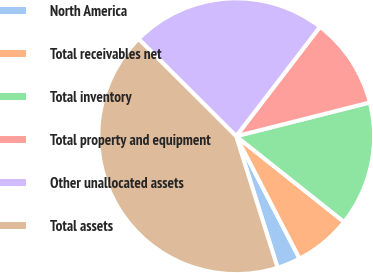Convert chart to OTSL. <chart><loc_0><loc_0><loc_500><loc_500><pie_chart><fcel>North America<fcel>Total receivables net<fcel>Total inventory<fcel>Total property and equipment<fcel>Other unallocated assets<fcel>Total assets<nl><fcel>2.75%<fcel>6.71%<fcel>14.62%<fcel>10.66%<fcel>22.93%<fcel>42.33%<nl></chart> 